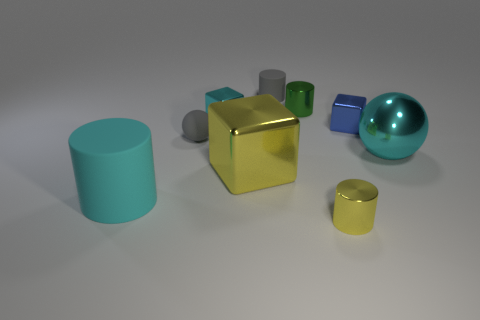How many large cyan rubber objects are there?
Offer a terse response. 1. Are there any rubber spheres right of the blue metallic cube?
Give a very brief answer. No. Is the material of the small thing in front of the big cyan shiny sphere the same as the tiny block that is on the right side of the large metal cube?
Your answer should be very brief. Yes. Is the number of small metal cylinders that are to the left of the tiny green thing less than the number of cyan cubes?
Give a very brief answer. Yes. What is the color of the matte cylinder that is in front of the blue metallic object?
Offer a terse response. Cyan. There is a cyan object that is on the left side of the ball that is to the left of the tiny blue cube; what is its material?
Your response must be concise. Rubber. Are there any blue objects of the same size as the green cylinder?
Your answer should be compact. Yes. What number of objects are either metal cylinders in front of the large cylinder or big metal things that are to the left of the tiny green object?
Your response must be concise. 2. There is a yellow metal thing that is behind the cyan matte cylinder; does it have the same size as the cyan object in front of the shiny ball?
Give a very brief answer. Yes. Are there any blue blocks that are behind the small metal block in front of the cyan block?
Make the answer very short. No. 